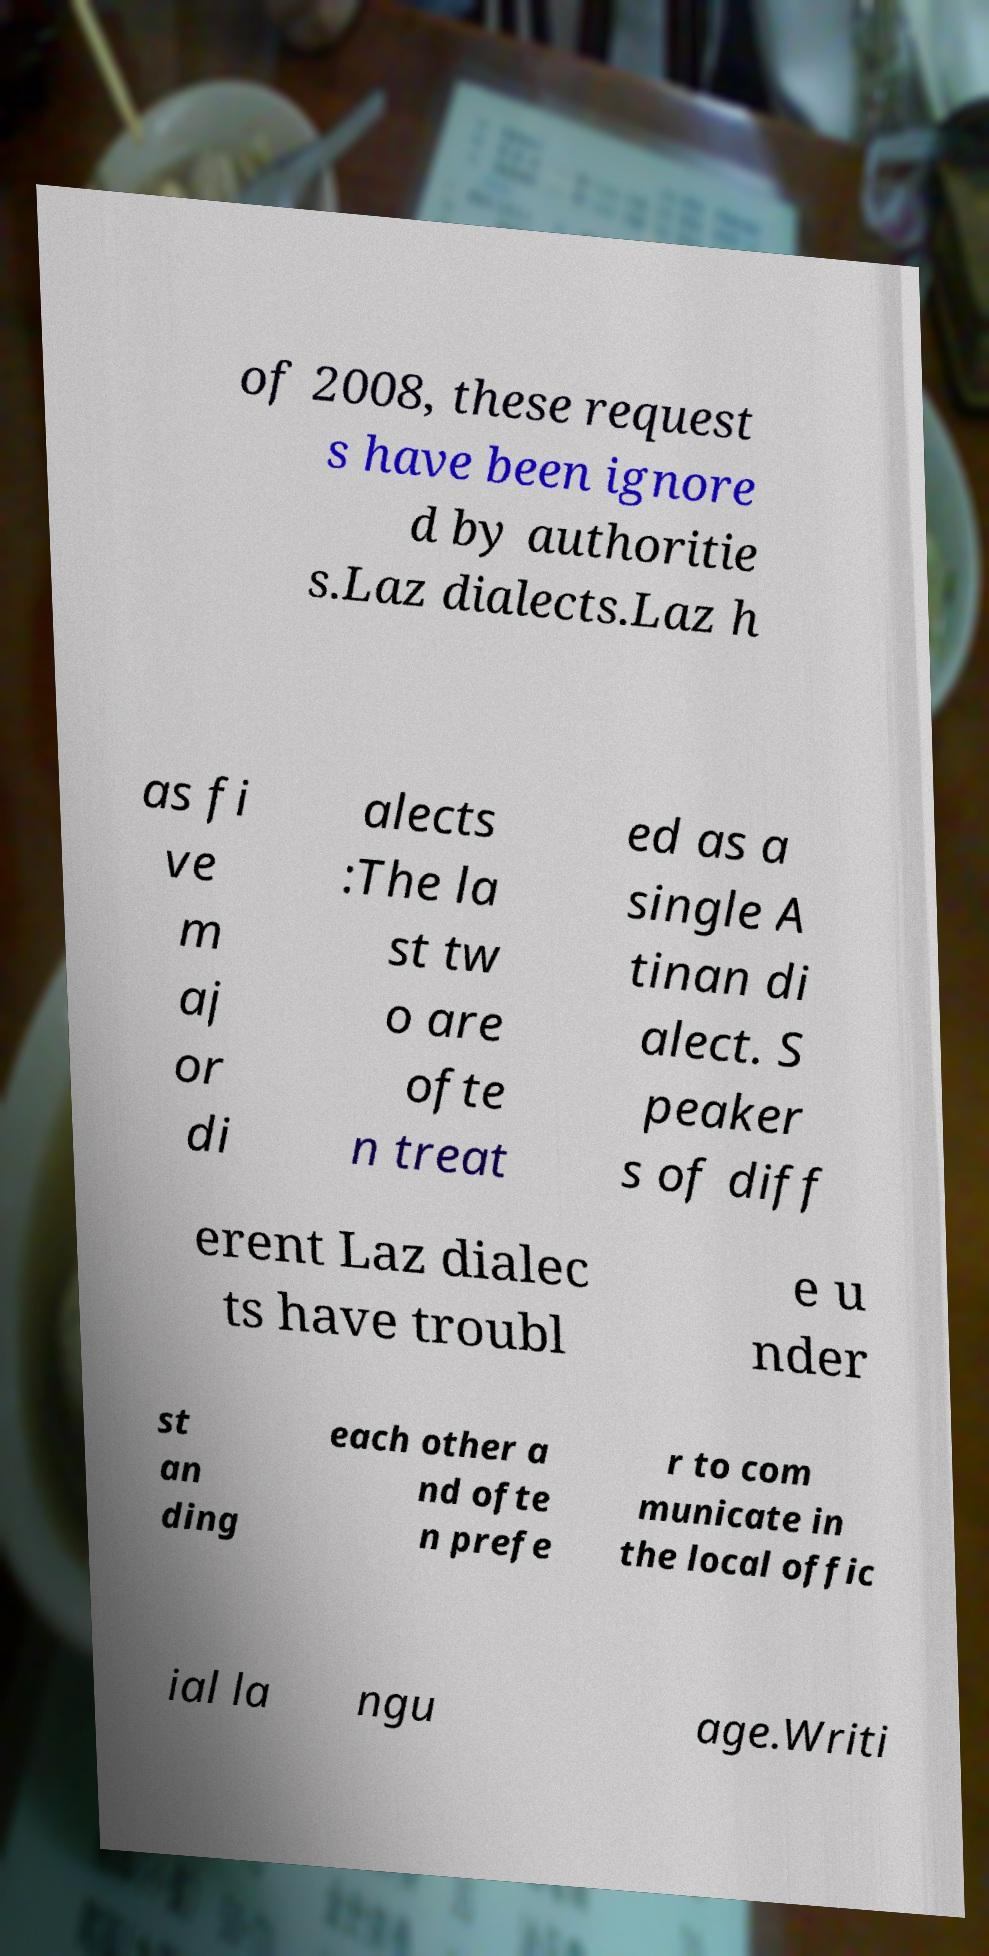Please identify and transcribe the text found in this image. of 2008, these request s have been ignore d by authoritie s.Laz dialects.Laz h as fi ve m aj or di alects :The la st tw o are ofte n treat ed as a single A tinan di alect. S peaker s of diff erent Laz dialec ts have troubl e u nder st an ding each other a nd ofte n prefe r to com municate in the local offic ial la ngu age.Writi 